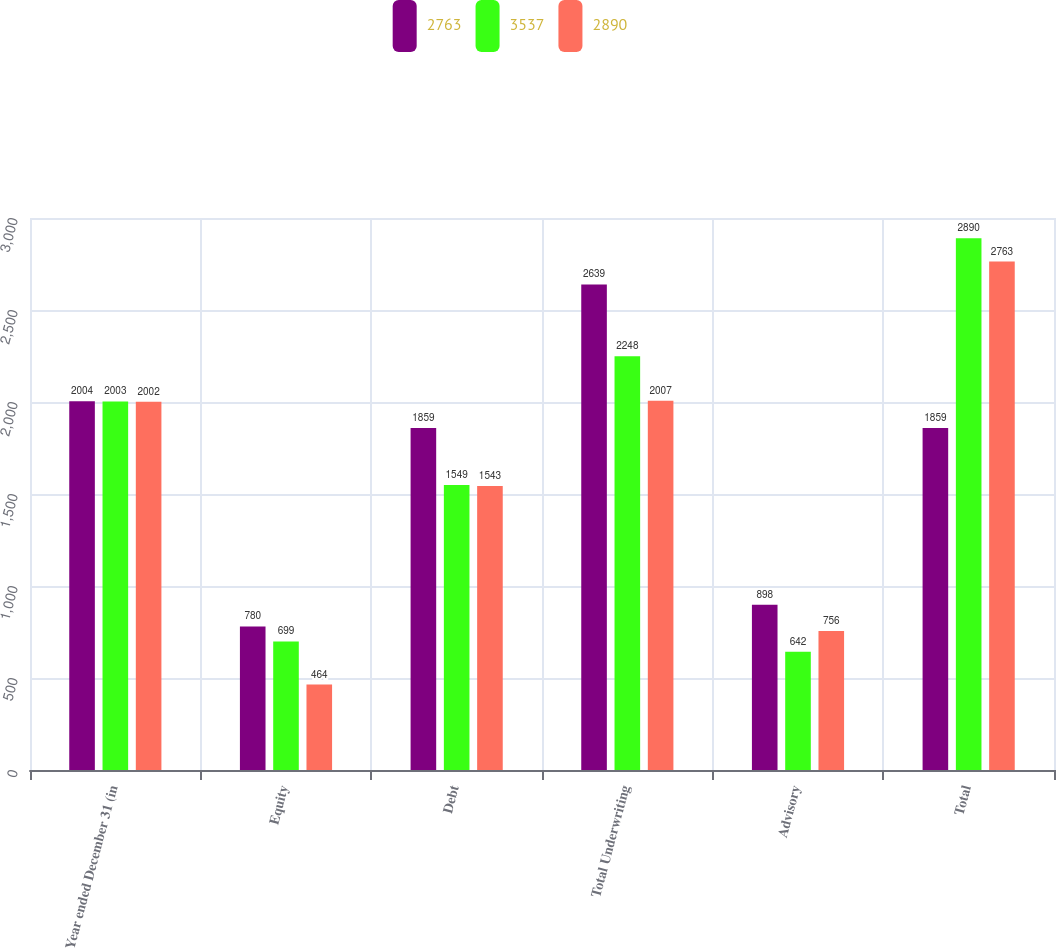Convert chart to OTSL. <chart><loc_0><loc_0><loc_500><loc_500><stacked_bar_chart><ecel><fcel>Year ended December 31 (in<fcel>Equity<fcel>Debt<fcel>Total Underwriting<fcel>Advisory<fcel>Total<nl><fcel>2763<fcel>2004<fcel>780<fcel>1859<fcel>2639<fcel>898<fcel>1859<nl><fcel>3537<fcel>2003<fcel>699<fcel>1549<fcel>2248<fcel>642<fcel>2890<nl><fcel>2890<fcel>2002<fcel>464<fcel>1543<fcel>2007<fcel>756<fcel>2763<nl></chart> 